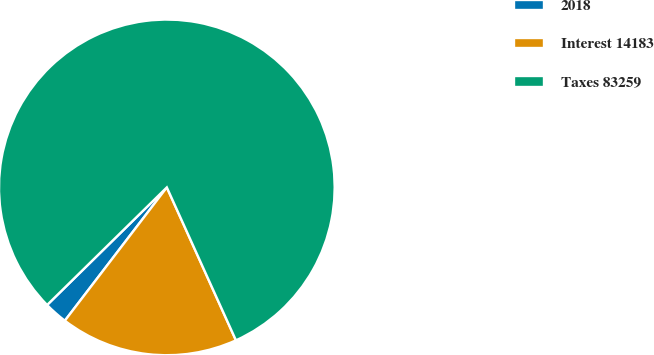<chart> <loc_0><loc_0><loc_500><loc_500><pie_chart><fcel>2018<fcel>Interest 14183<fcel>Taxes 83259<nl><fcel>2.25%<fcel>17.15%<fcel>80.6%<nl></chart> 